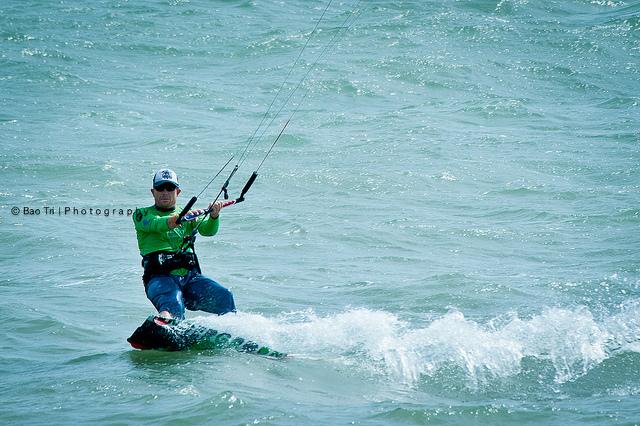What color hat is the man wearing?
Quick response, please. White. Who is the photographer?
Be succinct. Bao tri. What sport is this?
Write a very short answer. Parasailing. What is on the man's head?
Write a very short answer. Hat. What are the people riding on?
Short answer required. Surfboard. What is he doing?
Give a very brief answer. Parasailing. What color is the life jacket?
Concise answer only. Green. 